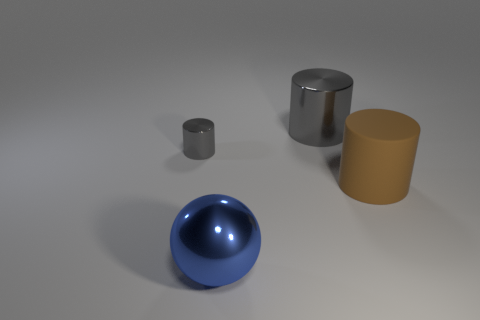Add 3 large brown matte things. How many objects exist? 7 Subtract all cylinders. How many objects are left? 1 Subtract all big rubber things. Subtract all large shiny objects. How many objects are left? 1 Add 2 large things. How many large things are left? 5 Add 2 large gray metal objects. How many large gray metal objects exist? 3 Subtract 2 gray cylinders. How many objects are left? 2 